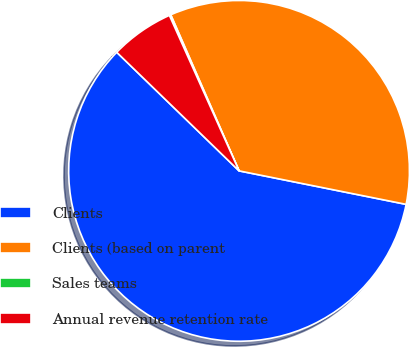Convert chart to OTSL. <chart><loc_0><loc_0><loc_500><loc_500><pie_chart><fcel>Clients<fcel>Clients (based on parent<fcel>Sales teams<fcel>Annual revenue retention rate<nl><fcel>59.11%<fcel>34.72%<fcel>0.14%<fcel>6.04%<nl></chart> 